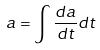Convert formula to latex. <formula><loc_0><loc_0><loc_500><loc_500>a = \int \frac { d a } { d t } d t</formula> 